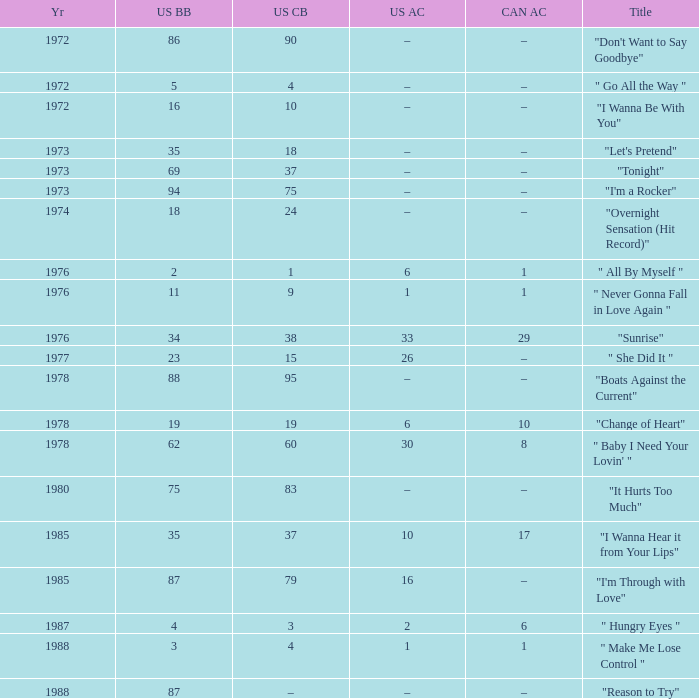What is the US cash box before 1978 with a US billboard of 35? 18.0. 